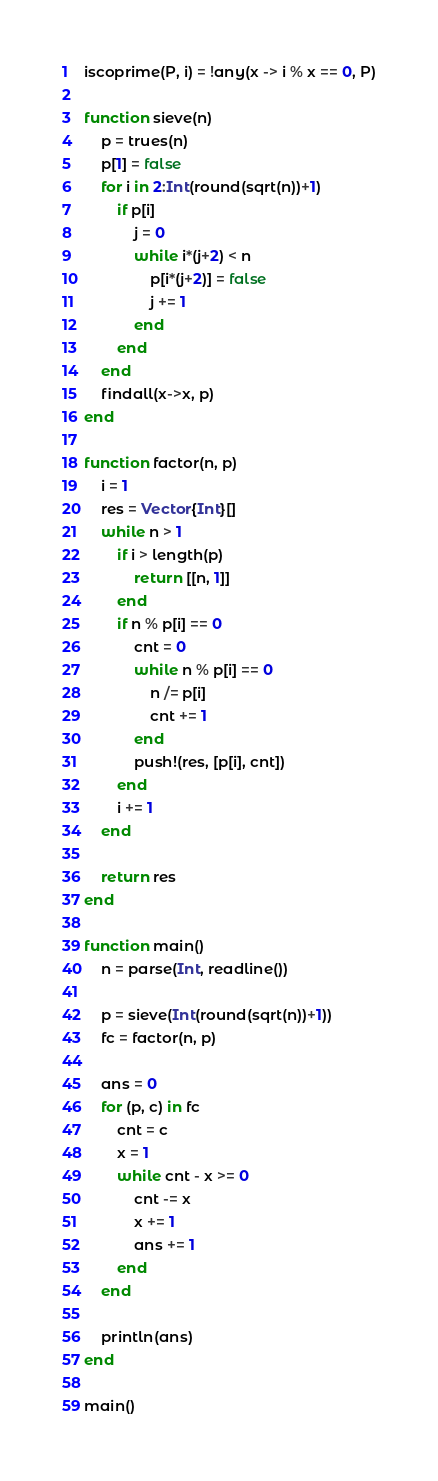Convert code to text. <code><loc_0><loc_0><loc_500><loc_500><_Julia_>iscoprime(P, i) = !any(x -> i % x == 0, P)

function sieve(n)
    p = trues(n)
    p[1] = false
    for i in 2:Int(round(sqrt(n))+1)
        if p[i]
            j = 0
            while i*(j+2) < n
                p[i*(j+2)] = false
                j += 1
            end
        end
    end
    findall(x->x, p)
end

function factor(n, p)
    i = 1
    res = Vector{Int}[]
    while n > 1
        if i > length(p)
            return [[n, 1]]
        end
        if n % p[i] == 0
            cnt = 0
            while n % p[i] == 0
                n /= p[i]
                cnt += 1
            end
            push!(res, [p[i], cnt])
        end
        i += 1
    end

    return res
end

function main()
    n = parse(Int, readline())
    
    p = sieve(Int(round(sqrt(n))+1))
    fc = factor(n, p)

    ans = 0
    for (p, c) in fc
        cnt = c
        x = 1
        while cnt - x >= 0
            cnt -= x
            x += 1
            ans += 1
        end
    end

    println(ans)
end

main()
</code> 